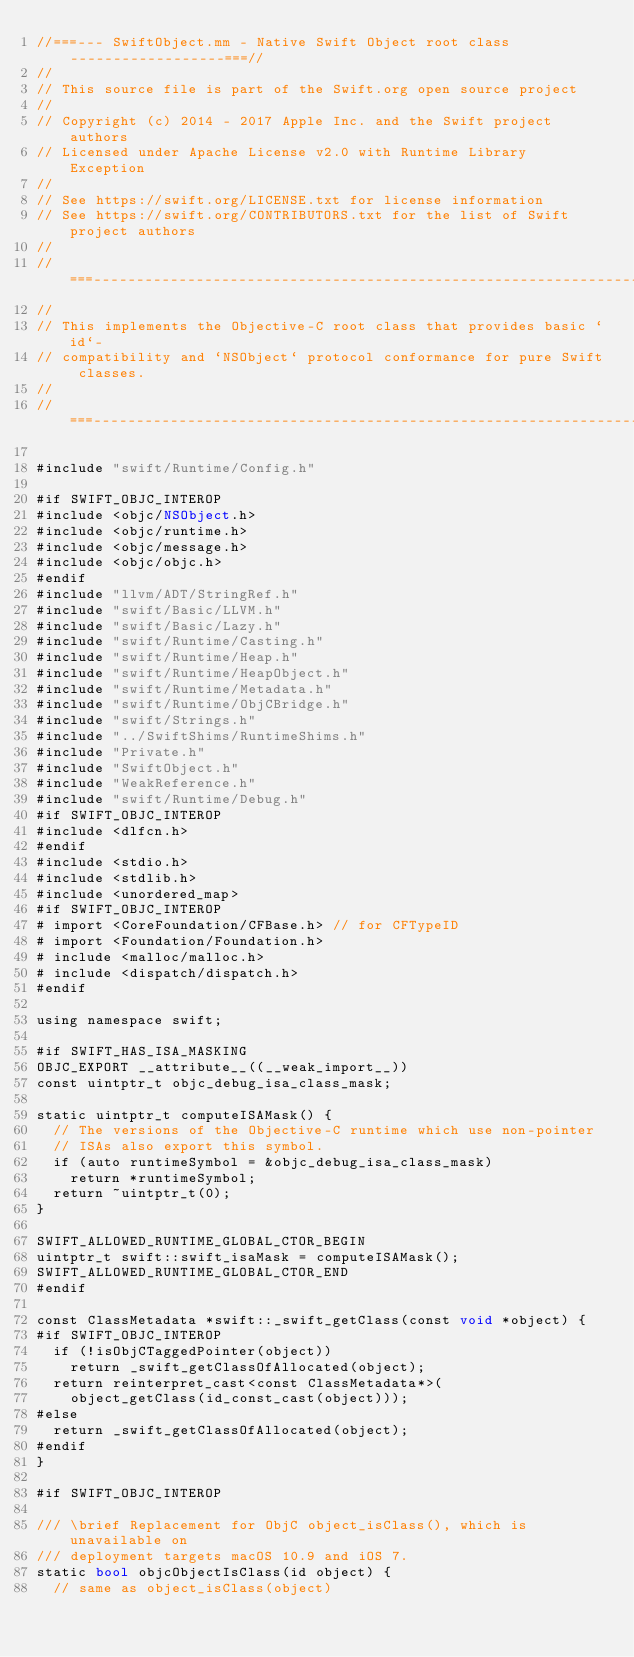Convert code to text. <code><loc_0><loc_0><loc_500><loc_500><_ObjectiveC_>//===--- SwiftObject.mm - Native Swift Object root class ------------------===//
//
// This source file is part of the Swift.org open source project
//
// Copyright (c) 2014 - 2017 Apple Inc. and the Swift project authors
// Licensed under Apache License v2.0 with Runtime Library Exception
//
// See https://swift.org/LICENSE.txt for license information
// See https://swift.org/CONTRIBUTORS.txt for the list of Swift project authors
//
//===----------------------------------------------------------------------===//
//
// This implements the Objective-C root class that provides basic `id`-
// compatibility and `NSObject` protocol conformance for pure Swift classes.
//
//===----------------------------------------------------------------------===//

#include "swift/Runtime/Config.h"

#if SWIFT_OBJC_INTEROP
#include <objc/NSObject.h>
#include <objc/runtime.h>
#include <objc/message.h>
#include <objc/objc.h>
#endif
#include "llvm/ADT/StringRef.h"
#include "swift/Basic/LLVM.h"
#include "swift/Basic/Lazy.h"
#include "swift/Runtime/Casting.h"
#include "swift/Runtime/Heap.h"
#include "swift/Runtime/HeapObject.h"
#include "swift/Runtime/Metadata.h"
#include "swift/Runtime/ObjCBridge.h"
#include "swift/Strings.h"
#include "../SwiftShims/RuntimeShims.h"
#include "Private.h"
#include "SwiftObject.h"
#include "WeakReference.h"
#include "swift/Runtime/Debug.h"
#if SWIFT_OBJC_INTEROP
#include <dlfcn.h>
#endif
#include <stdio.h>
#include <stdlib.h>
#include <unordered_map>
#if SWIFT_OBJC_INTEROP
# import <CoreFoundation/CFBase.h> // for CFTypeID
# import <Foundation/Foundation.h>
# include <malloc/malloc.h>
# include <dispatch/dispatch.h>
#endif

using namespace swift;

#if SWIFT_HAS_ISA_MASKING
OBJC_EXPORT __attribute__((__weak_import__))
const uintptr_t objc_debug_isa_class_mask;

static uintptr_t computeISAMask() {
  // The versions of the Objective-C runtime which use non-pointer
  // ISAs also export this symbol.
  if (auto runtimeSymbol = &objc_debug_isa_class_mask)
    return *runtimeSymbol;
  return ~uintptr_t(0);
}

SWIFT_ALLOWED_RUNTIME_GLOBAL_CTOR_BEGIN
uintptr_t swift::swift_isaMask = computeISAMask();
SWIFT_ALLOWED_RUNTIME_GLOBAL_CTOR_END
#endif

const ClassMetadata *swift::_swift_getClass(const void *object) {
#if SWIFT_OBJC_INTEROP
  if (!isObjCTaggedPointer(object))
    return _swift_getClassOfAllocated(object);
  return reinterpret_cast<const ClassMetadata*>(
    object_getClass(id_const_cast(object)));
#else
  return _swift_getClassOfAllocated(object);
#endif
}

#if SWIFT_OBJC_INTEROP

/// \brief Replacement for ObjC object_isClass(), which is unavailable on
/// deployment targets macOS 10.9 and iOS 7.
static bool objcObjectIsClass(id object) {
  // same as object_isClass(object)</code> 